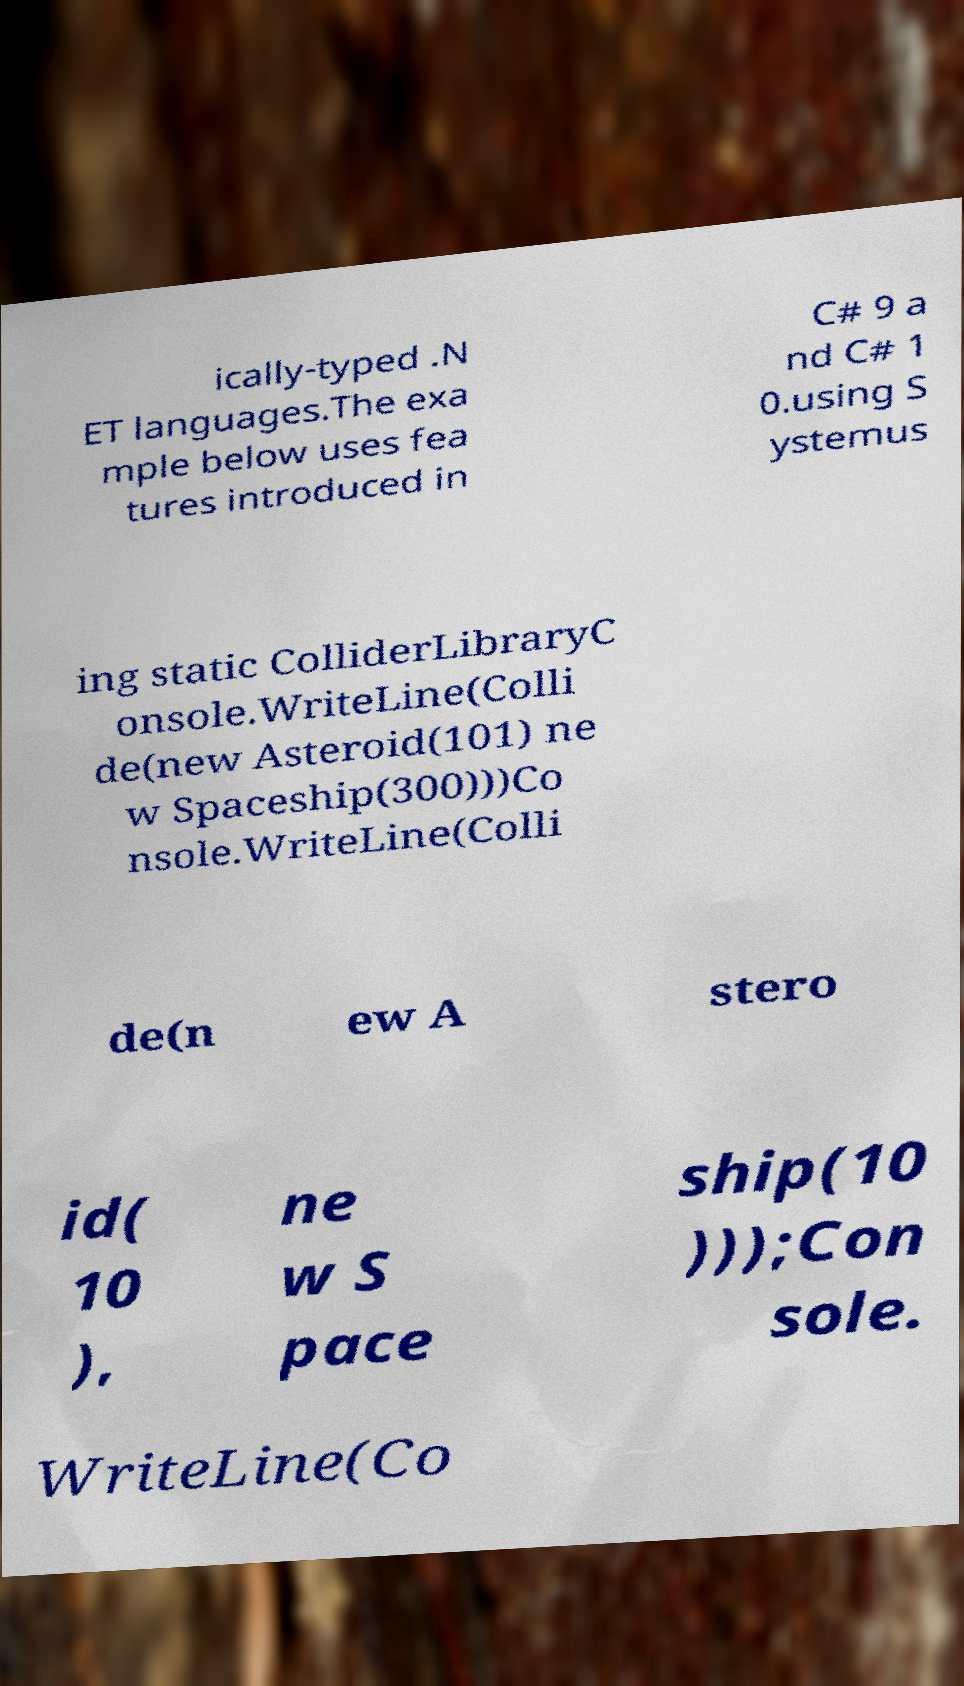What messages or text are displayed in this image? I need them in a readable, typed format. ically-typed .N ET languages.The exa mple below uses fea tures introduced in C# 9 a nd C# 1 0.using S ystemus ing static ColliderLibraryC onsole.WriteLine(Colli de(new Asteroid(101) ne w Spaceship(300)))Co nsole.WriteLine(Colli de(n ew A stero id( 10 ), ne w S pace ship(10 )));Con sole. WriteLine(Co 